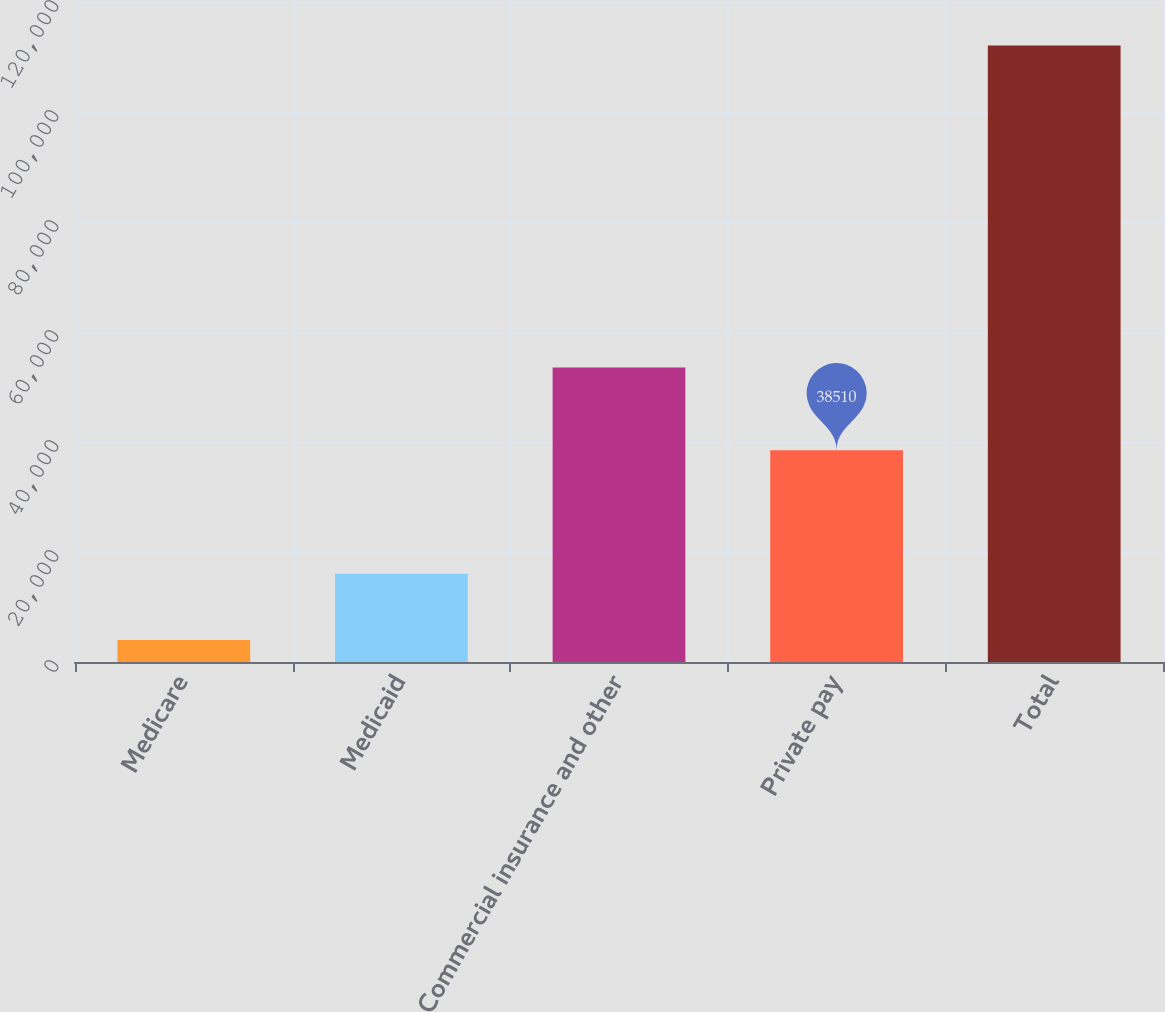Convert chart to OTSL. <chart><loc_0><loc_0><loc_500><loc_500><bar_chart><fcel>Medicare<fcel>Medicaid<fcel>Commercial insurance and other<fcel>Private pay<fcel>Total<nl><fcel>3993<fcel>16049<fcel>53539<fcel>38510<fcel>112091<nl></chart> 